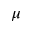<formula> <loc_0><loc_0><loc_500><loc_500>\mu</formula> 